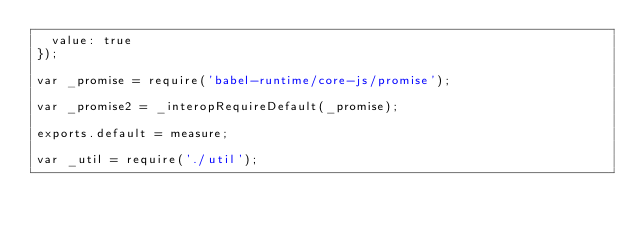Convert code to text. <code><loc_0><loc_0><loc_500><loc_500><_JavaScript_>  value: true
});

var _promise = require('babel-runtime/core-js/promise');

var _promise2 = _interopRequireDefault(_promise);

exports.default = measure;

var _util = require('./util');
</code> 